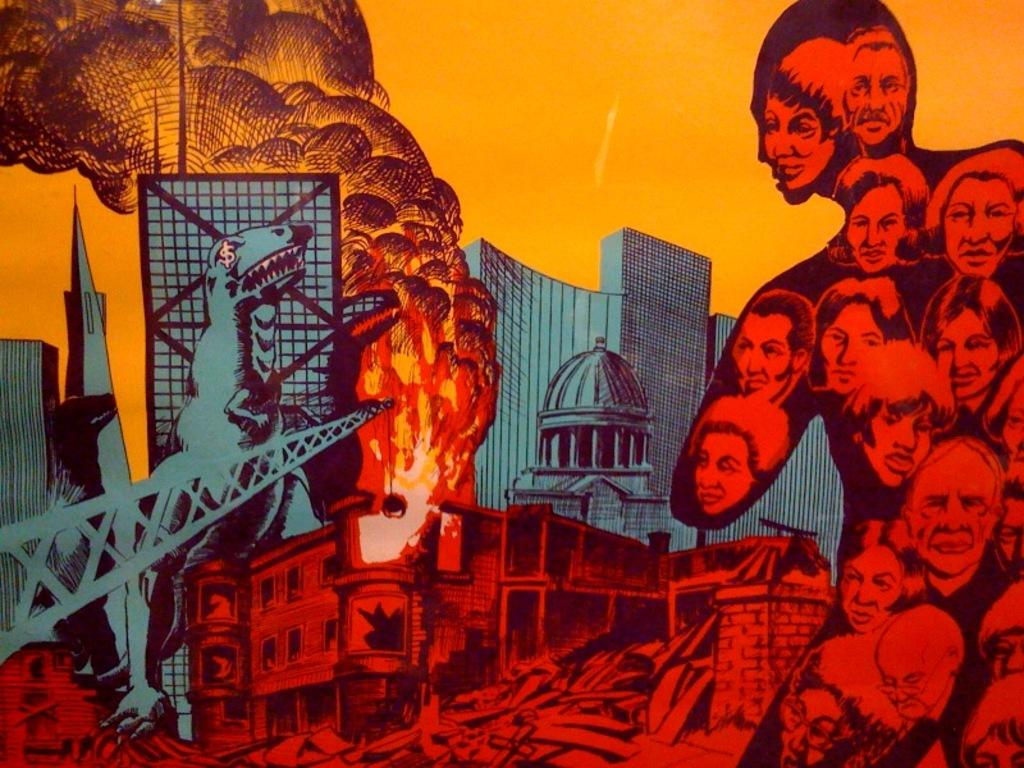What is the main subject of the poster in the image? The poster contains images of people's heads, animals, fire, buildings, and the sky. Can you describe the images of people's heads on the poster? The poster contains images of people's heads. What other types of images are present on the poster? The poster also contains images of animals, fire, buildings, and the sky. What type of needle is used to sew the cushion in the image? There is no needle or cushion present in the image; it only features a poster with various images. 